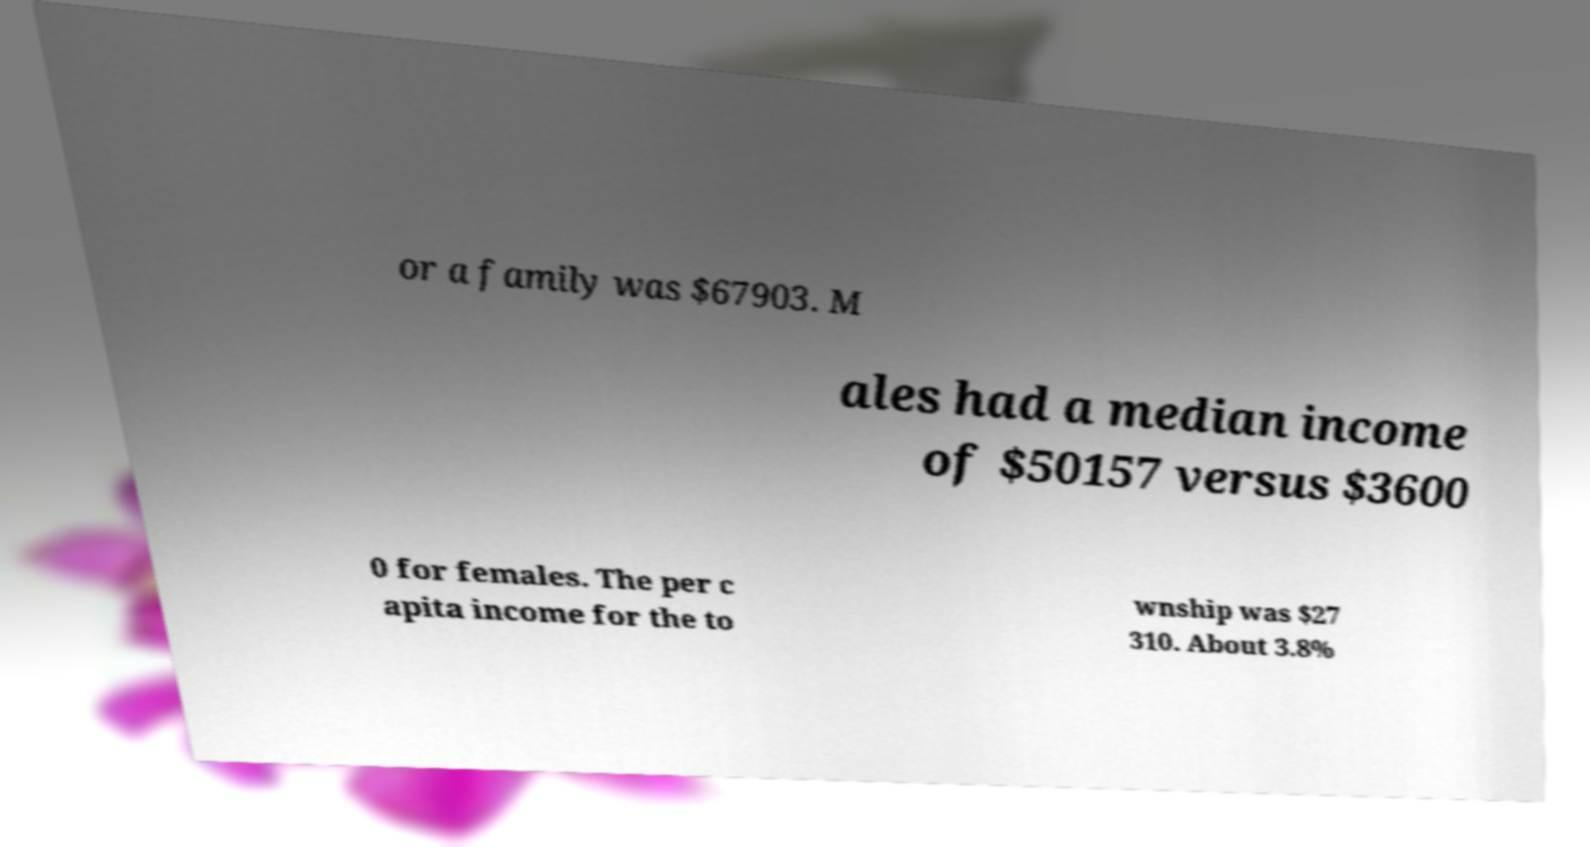Please read and relay the text visible in this image. What does it say? or a family was $67903. M ales had a median income of $50157 versus $3600 0 for females. The per c apita income for the to wnship was $27 310. About 3.8% 